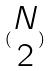Convert formula to latex. <formula><loc_0><loc_0><loc_500><loc_500>( \begin{matrix} N \\ 2 \end{matrix} )</formula> 